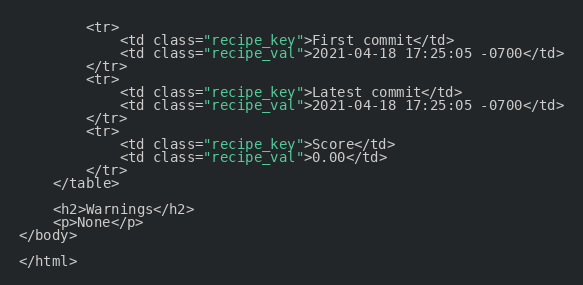<code> <loc_0><loc_0><loc_500><loc_500><_HTML_>        <tr>
            <td class="recipe_key">First commit</td>
            <td class="recipe_val">2021-04-18 17:25:05 -0700</td>
        </tr>
        <tr>
            <td class="recipe_key">Latest commit</td>
            <td class="recipe_val">2021-04-18 17:25:05 -0700</td>
        </tr>
        <tr>
            <td class="recipe_key">Score</td>
            <td class="recipe_val">0.00</td>
        </tr>
    </table>

    <h2>Warnings</h2>
    <p>None</p>
</body>

</html>
</code> 